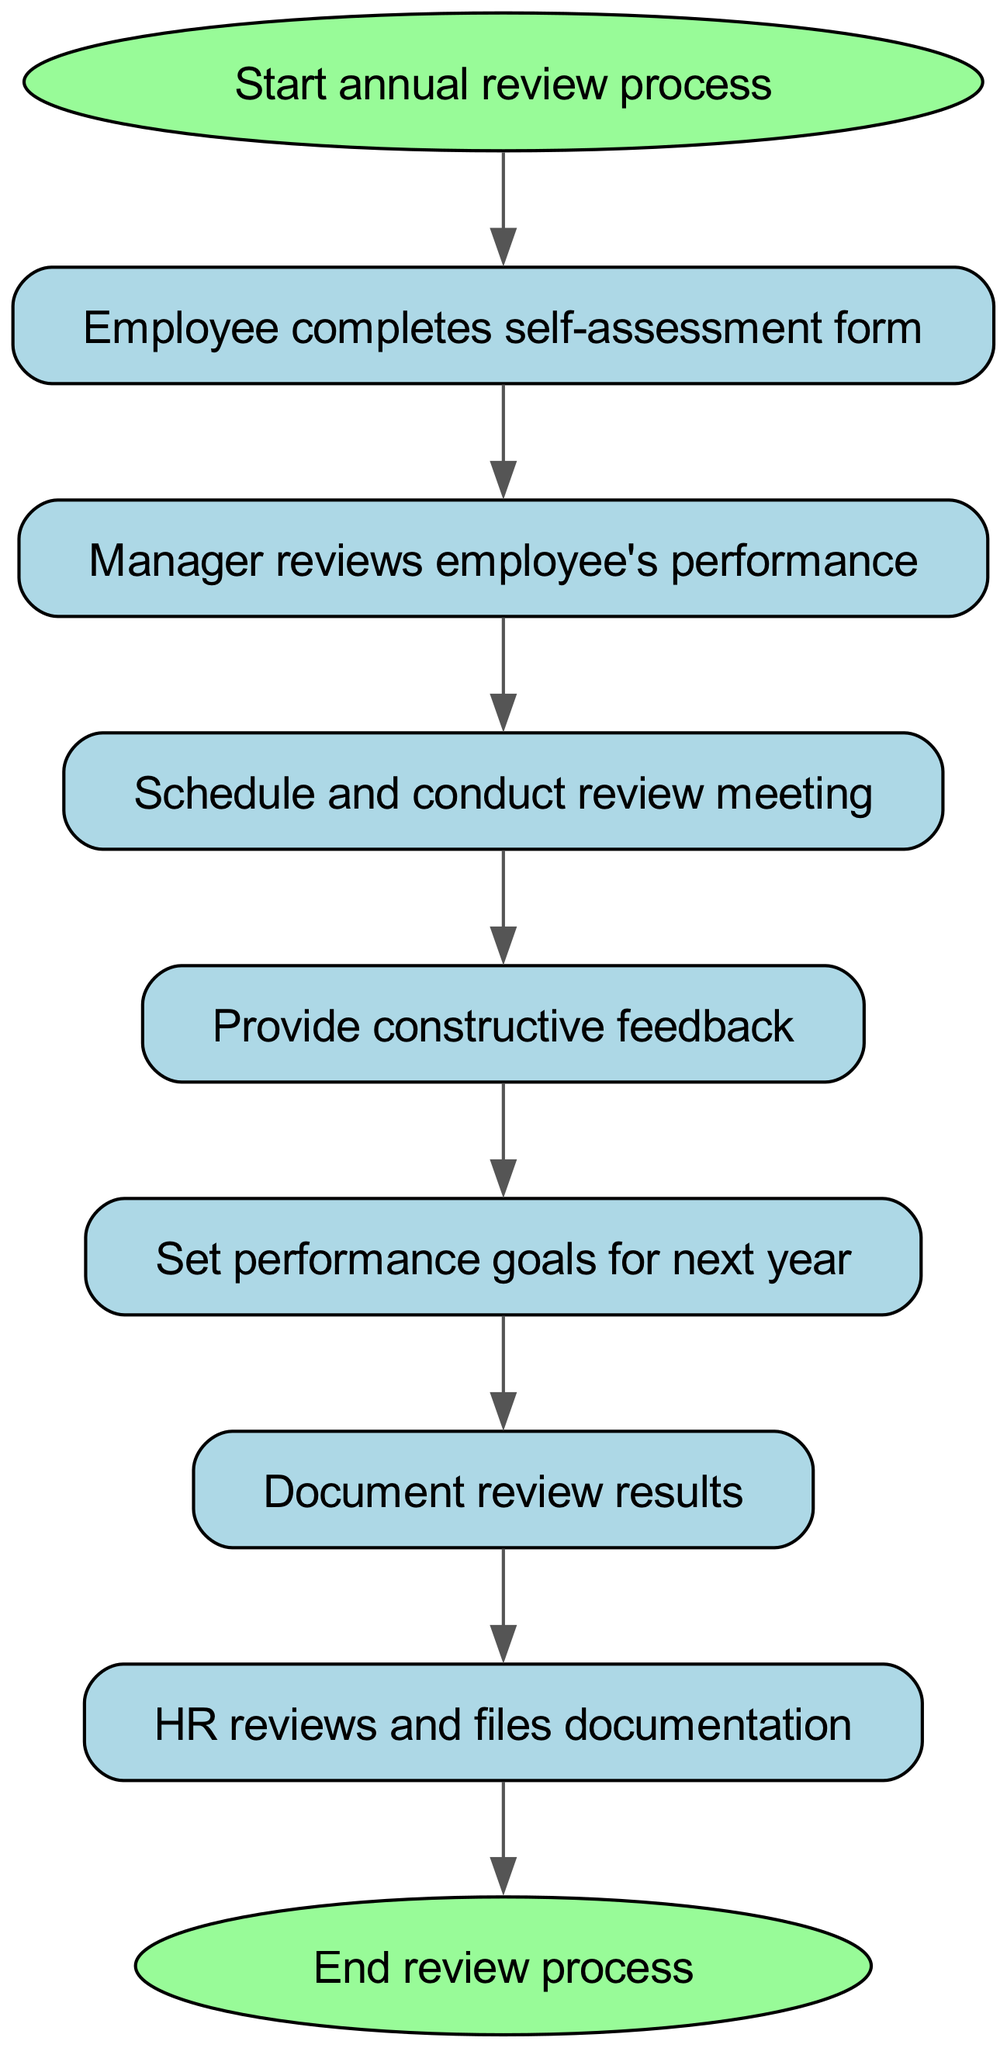What is the first step in the annual review process? The first step is specified in the diagram as "Start annual review process," which is the starting node.
Answer: Start annual review process How many nodes are in the flowchart? Counting all the unique nodes listed in the diagram, there are a total of eight nodes representing different steps in the process.
Answer: 8 What is the final action taken in the review process? The last step, as indicated in the diagram, is "End review process," which signifies the conclusion of the entire flow.
Answer: End review process What comes after the "Provide constructive feedback" step? The diagram shows a directional flow where after "Provide constructive feedback," the next step is "Set performance goals for next year."
Answer: Set performance goals for next year What is the relationship between "Manager reviews employee's performance" and "Schedule and conduct review meeting"? The flowchart indicates that after the manager reviews the employee's performance, the next action to be taken is to schedule and conduct the review meeting, showing a direct progression from one step to the next.
Answer: Schedule and conduct review meeting Which node is reviewed by HR? The diagram specifies that after the documentation of review results, HR reviews and files the documentation, making "HR reviews and files documentation" the action associated with the HR node.
Answer: HR reviews and files documentation What is the total number of edges in the flowchart? By counting the connections (edges) between the nodes in the diagram, we see there are a total of seven connections showing the flow from one step to another.
Answer: 7 What is the immediate action after "Document review results"? According to the flowchart, the immediate action that follows "Document review results" is "HR reviews and files documentation." This indicates the next step in the process.
Answer: HR reviews and files documentation Is "Employee completes self-assessment form" a starting or ending action? The flowchart places "Employee completes self-assessment form" directly after the starting action in the flow, indicating that it is a starting action rather than an ending one.
Answer: Starting action 